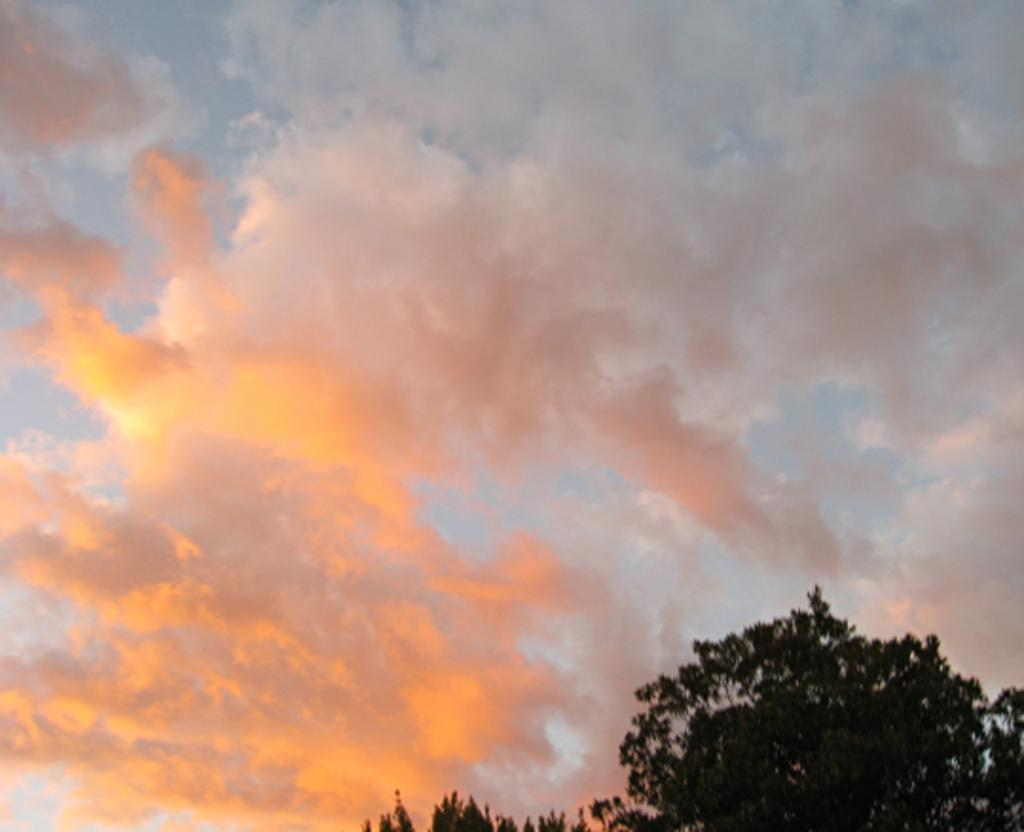What type of vegetation can be seen in the image? There are trees in the image. What is the condition of the sky in the image? The sky is cloudy in the image. How many balls are visible in the image? There are no balls present in the image. What degree of temperature can be felt in the image? The image does not convey temperature information, so it cannot be determined from the image. 